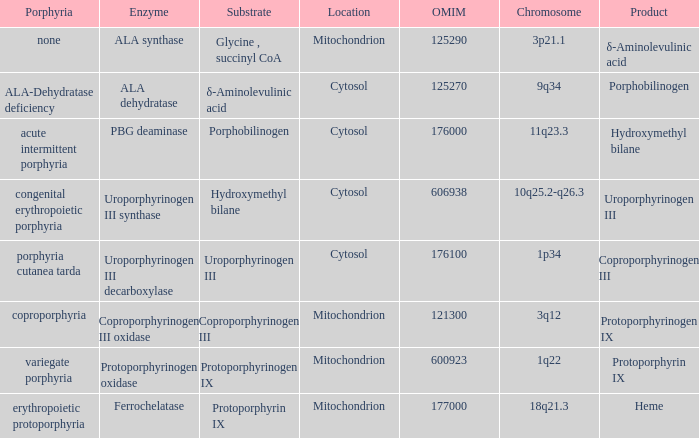What is the location of the enzyme Uroporphyrinogen iii Synthase? Cytosol. 